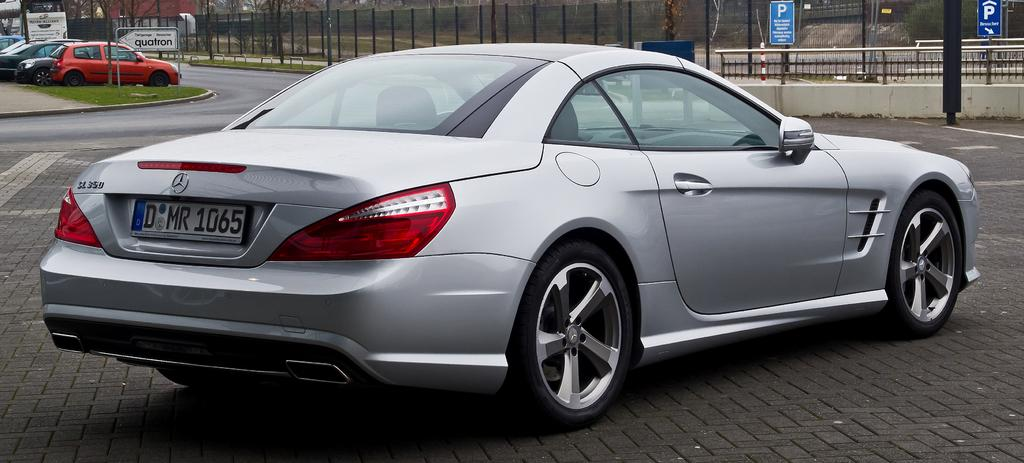What is the main subject of the image? The main subject of the image is a car on the road. Can you describe the background of the image? In the background of the image, there are cars, name boards, fences, sign boards, trees, grass, and some unspecified objects. How many cars can be seen in the image? There is one car on the road, and there are additional cars visible in the background. What type of flame can be seen coming from the exhaust of the car in the image? There is no flame visible coming from the exhaust of the car in the image. Are there any dinosaurs present in the image? No, there are no dinosaurs present in the image. 